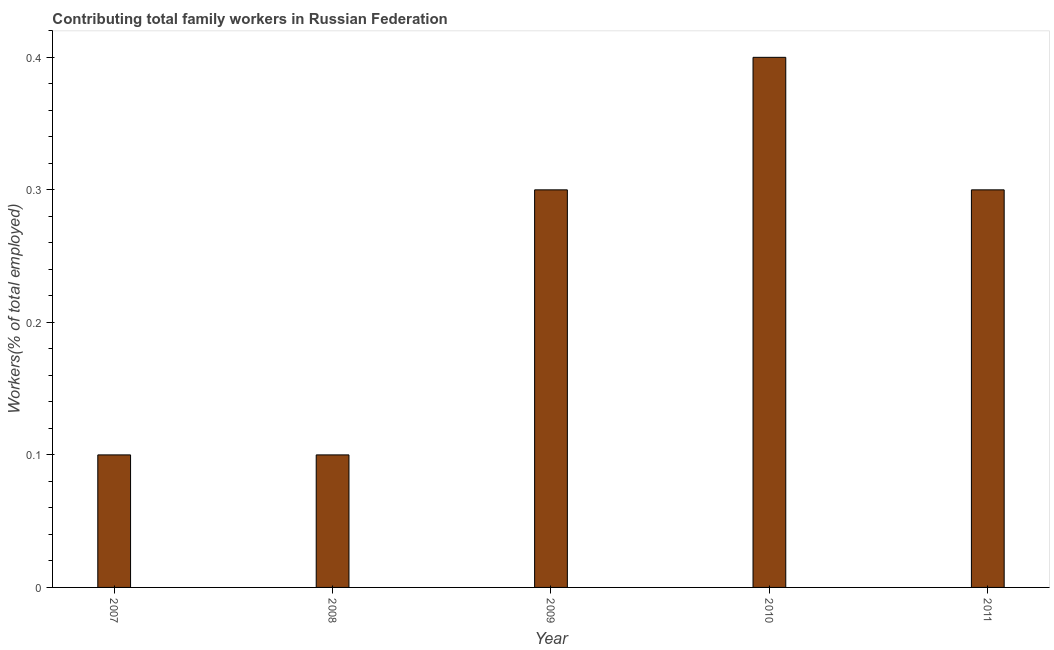Does the graph contain any zero values?
Ensure brevity in your answer.  No. What is the title of the graph?
Offer a very short reply. Contributing total family workers in Russian Federation. What is the label or title of the X-axis?
Your response must be concise. Year. What is the label or title of the Y-axis?
Your response must be concise. Workers(% of total employed). What is the contributing family workers in 2010?
Keep it short and to the point. 0.4. Across all years, what is the maximum contributing family workers?
Offer a very short reply. 0.4. Across all years, what is the minimum contributing family workers?
Your response must be concise. 0.1. In which year was the contributing family workers minimum?
Provide a short and direct response. 2007. What is the sum of the contributing family workers?
Keep it short and to the point. 1.2. What is the difference between the contributing family workers in 2008 and 2011?
Your answer should be compact. -0.2. What is the average contributing family workers per year?
Your answer should be very brief. 0.24. What is the median contributing family workers?
Offer a terse response. 0.3. Do a majority of the years between 2008 and 2009 (inclusive) have contributing family workers greater than 0.14 %?
Your answer should be very brief. No. What is the ratio of the contributing family workers in 2007 to that in 2011?
Give a very brief answer. 0.33. What is the difference between the highest and the second highest contributing family workers?
Keep it short and to the point. 0.1. Is the sum of the contributing family workers in 2007 and 2011 greater than the maximum contributing family workers across all years?
Provide a short and direct response. Yes. How many bars are there?
Keep it short and to the point. 5. Are all the bars in the graph horizontal?
Offer a very short reply. No. How many years are there in the graph?
Offer a terse response. 5. Are the values on the major ticks of Y-axis written in scientific E-notation?
Your answer should be compact. No. What is the Workers(% of total employed) of 2007?
Offer a very short reply. 0.1. What is the Workers(% of total employed) of 2008?
Provide a succinct answer. 0.1. What is the Workers(% of total employed) of 2009?
Ensure brevity in your answer.  0.3. What is the Workers(% of total employed) in 2010?
Provide a succinct answer. 0.4. What is the Workers(% of total employed) in 2011?
Provide a succinct answer. 0.3. What is the difference between the Workers(% of total employed) in 2007 and 2009?
Your answer should be very brief. -0.2. What is the difference between the Workers(% of total employed) in 2007 and 2010?
Ensure brevity in your answer.  -0.3. What is the difference between the Workers(% of total employed) in 2007 and 2011?
Your answer should be compact. -0.2. What is the difference between the Workers(% of total employed) in 2008 and 2009?
Your answer should be compact. -0.2. What is the ratio of the Workers(% of total employed) in 2007 to that in 2009?
Give a very brief answer. 0.33. What is the ratio of the Workers(% of total employed) in 2007 to that in 2010?
Offer a terse response. 0.25. What is the ratio of the Workers(% of total employed) in 2007 to that in 2011?
Your answer should be very brief. 0.33. What is the ratio of the Workers(% of total employed) in 2008 to that in 2009?
Ensure brevity in your answer.  0.33. What is the ratio of the Workers(% of total employed) in 2008 to that in 2011?
Ensure brevity in your answer.  0.33. What is the ratio of the Workers(% of total employed) in 2009 to that in 2011?
Provide a succinct answer. 1. What is the ratio of the Workers(% of total employed) in 2010 to that in 2011?
Make the answer very short. 1.33. 